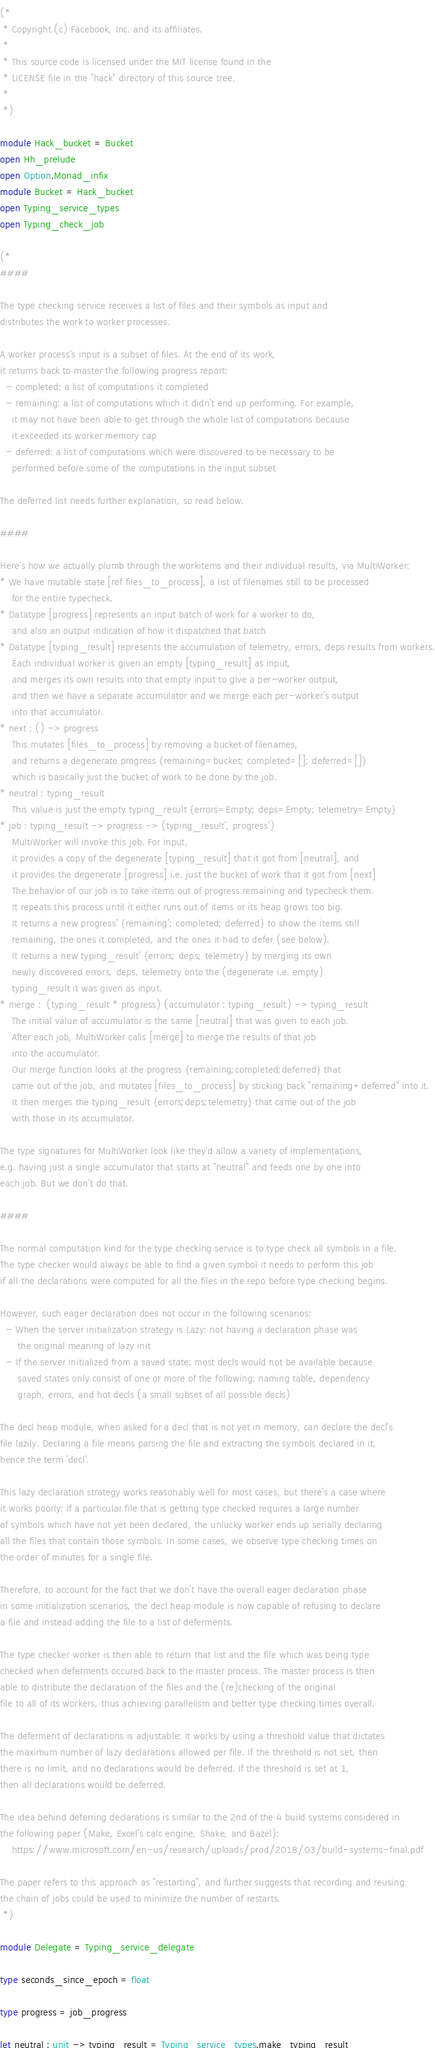Convert code to text. <code><loc_0><loc_0><loc_500><loc_500><_OCaml_>(*
 * Copyright (c) Facebook, Inc. and its affiliates.
 *
 * This source code is licensed under the MIT license found in the
 * LICENSE file in the "hack" directory of this source tree.
 *
 *)

module Hack_bucket = Bucket
open Hh_prelude
open Option.Monad_infix
module Bucket = Hack_bucket
open Typing_service_types
open Typing_check_job

(*
####

The type checking service receives a list of files and their symbols as input and
distributes the work to worker processes.

A worker process's input is a subset of files. At the end of its work,
it returns back to master the following progress report:
  - completed: a list of computations it completed
  - remaining: a list of computations which it didn't end up performing. For example,
    it may not have been able to get through the whole list of computations because
    it exceeded its worker memory cap
  - deferred: a list of computations which were discovered to be necessary to be
    performed before some of the computations in the input subset

The deferred list needs further explanation, so read below.

####

Here's how we actually plumb through the workitems and their individual results, via MultiWorker:
* We have mutable state [ref files_to_process], a list of filenames still to be processed
    for the entire typecheck.
* Datatype [progress] represents an input batch of work for a worker to do,
    and also an output indication of how it dispatched that batch
* Datatype [typing_result] represents the accumulation of telemetry, errors, deps results from workers.
    Each individual worker is given an empty [typing_result] as input,
    and merges its own results into that empty input to give a per-worker output,
    and then we have a separate accumulator and we merge each per-worker's output
    into that accumulator.
* next : () -> progress
    This mutates [files_to_process] by removing a bucket of filenames,
    and returns a degenerate progress {remaining=bucket; completed=[]; deferred=[]}
    which is basically just the bucket of work to be done by the job.
* neutral : typing_result
    This value is just the empty typing_result {errors=Empty; deps=Empty; telemetry=Empty}
* job : typing_result -> progress -> (typing_result', progress')
    MultiWorker will invoke this job. For input,
    it provides a copy of the degenerate [typing_result] that it got from [neutral], and
    it provides the degenerate [progress] i.e. just the bucket of work that it got from [next]
    The behavior of our job is to take items out of progress.remaining and typecheck them.
    It repeats this process until it either runs out of items or its heap grows too big.
    It returns a new progress' {remaining'; completed; deferred} to show the items still
    remaining, the ones it completed, and the ones it had to defer (see below).
    It returns a new typing_result' {errors; deps; telemetry} by merging its own
    newly discovered errors, deps, telemetry onto the (degenerate i.e. empty)
    typing_result it was given as input.
* merge :  (typing_result * progress) (accumulator : typing_result) -> typing_result
    The initial value of accumulator is the same [neutral] that was given to each job.
    After each job, MultiWorker calls [merge] to merge the results of that job
    into the accumulator.
    Our merge function looks at the progress {remaining;completed;deferred} that
    came out of the job, and mutates [files_to_process] by sticking back "remaining+deferred" into it.
    It then merges the typing_result {errors;deps;telemetry} that came out of the job
    with those in its accumulator.

The type signatures for MultiWorker look like they'd allow a variety of implementations,
e.g. having just a single accumulator that starts at "neutral" and feeds one by one into
each job. But we don't do that.

####

The normal computation kind for the type checking service is to type check all symbols in a file.
The type checker would always be able to find a given symbol it needs to perform this job
if all the declarations were computed for all the files in the repo before type checking begins.

However, such eager declaration does not occur in the following scenarios:
  - When the server initialization strategy is Lazy: not having a declaration phase was
      the original meaning of lazy init
  - If the server initialized from a saved state: most decls would not be available because
      saved states only consist of one or more of the following: naming table, dependency
      graph, errors, and hot decls (a small subset of all possible decls)

The decl heap module, when asked for a decl that is not yet in memory, can declare the decl's
file lazily. Declaring a file means parsing the file and extracting the symbols declared in it,
hence the term 'decl'.

This lazy declaration strategy works reasonably well for most cases, but there's a case where
it works poorly: if a particular file that is getting type checked requires a large number
of symbols which have not yet been declared, the unlucky worker ends up serially declaring
all the files that contain those symbols. In some cases, we observe type checking times on
the order of minutes for a single file.

Therefore, to account for the fact that we don't have the overall eager declaration phase
in some initialization scenarios, the decl heap module is now capable of refusing to declare
a file and instead adding the file to a list of deferments.

The type checker worker is then able to return that list and the file which was being type
checked when deferments occured back to the master process. The master process is then
able to distribute the declaration of the files and the (re)checking of the original
file to all of its workers, thus achieving parallelism and better type checking times overall.

The deferment of declarations is adjustable: it works by using a threshold value that dictates
the maximum number of lazy declarations allowed per file. If the threshold is not set, then
there is no limit, and no declarations would be deferred. If the threshold is set at 1,
then all declarations would be deferred.

The idea behind deferring declarations is similar to the 2nd of the 4 build systems considered in
the following paper (Make, Excel's calc engine, Shake, and Bazel):
    https://www.microsoft.com/en-us/research/uploads/prod/2018/03/build-systems-final.pdf

The paper refers to this approach as "restarting", and further suggests that recording and reusing
the chain of jobs could be used to minimize the number of restarts.
 *)

module Delegate = Typing_service_delegate

type seconds_since_epoch = float

type progress = job_progress

let neutral : unit -> typing_result = Typing_service_types.make_typing_result
</code> 